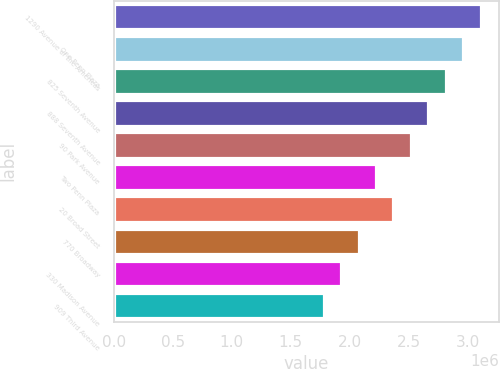Convert chart. <chart><loc_0><loc_0><loc_500><loc_500><bar_chart><fcel>1290 Avenue of the Americas<fcel>One Penn Plaza<fcel>825 Seventh Avenue<fcel>888 Seventh Avenue<fcel>90 Park Avenue<fcel>Two Penn Plaza<fcel>20 Broad Street<fcel>770 Broadway<fcel>330 Madison Avenue<fcel>909 Third Avenue<nl><fcel>3.1098e+06<fcel>2.962e+06<fcel>2.8142e+06<fcel>2.6664e+06<fcel>2.5186e+06<fcel>2.223e+06<fcel>2.3708e+06<fcel>2.0752e+06<fcel>1.9274e+06<fcel>1.7796e+06<nl></chart> 